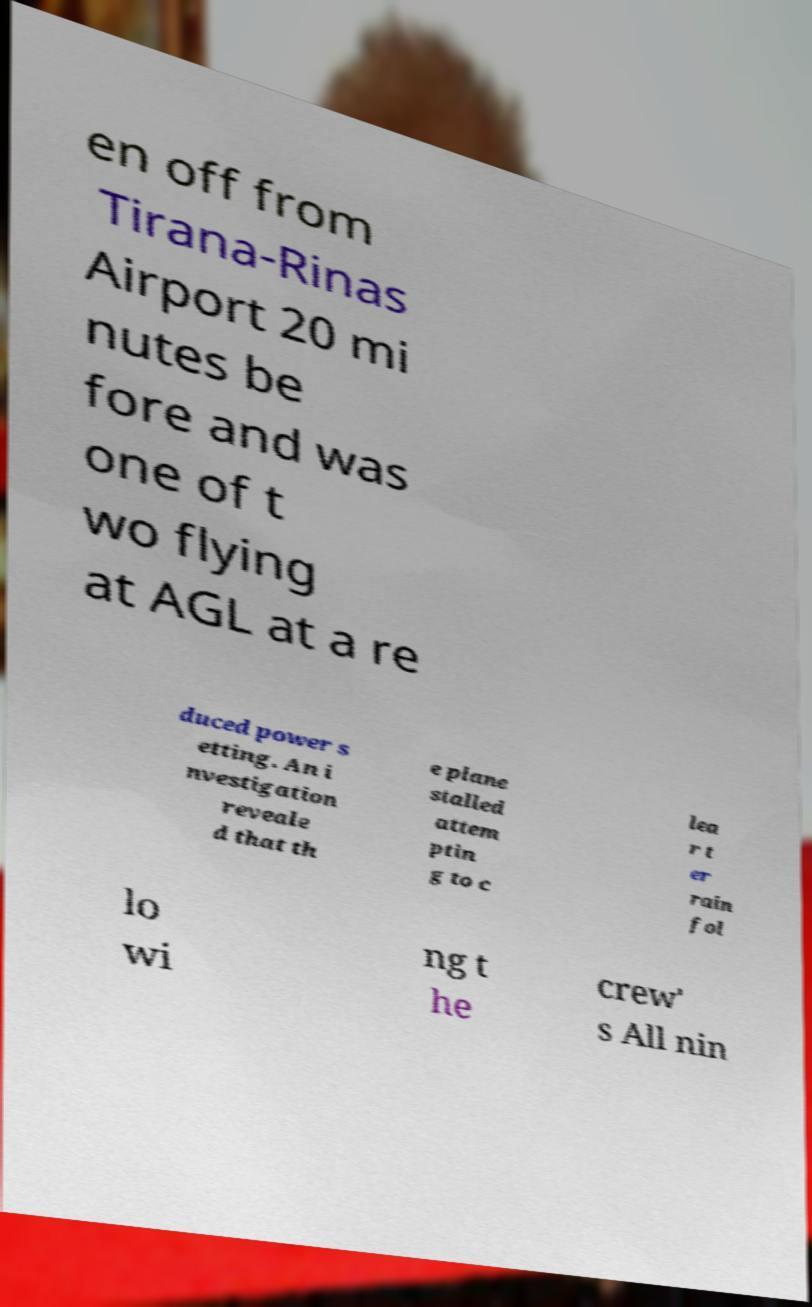Can you read and provide the text displayed in the image?This photo seems to have some interesting text. Can you extract and type it out for me? en off from Tirana-Rinas Airport 20 mi nutes be fore and was one of t wo flying at AGL at a re duced power s etting. An i nvestigation reveale d that th e plane stalled attem ptin g to c lea r t er rain fol lo wi ng t he crew' s All nin 